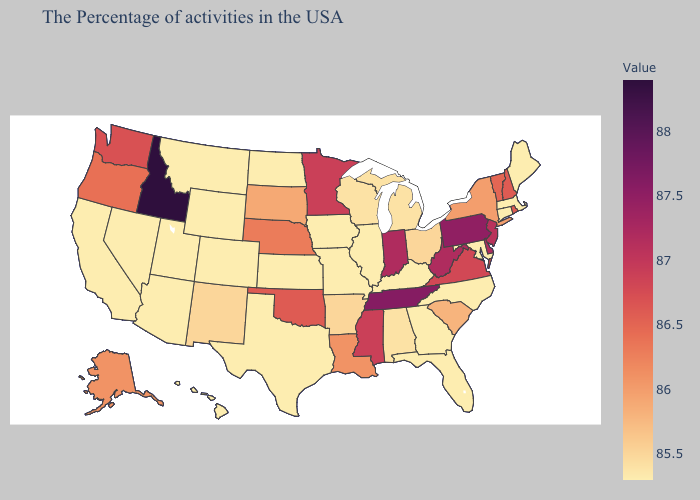Does the map have missing data?
Be succinct. No. Among the states that border New Jersey , does Delaware have the highest value?
Keep it brief. No. Which states have the lowest value in the USA?
Be succinct. Maine, Massachusetts, Connecticut, Maryland, North Carolina, Florida, Georgia, Kentucky, Illinois, Missouri, Iowa, Kansas, Texas, North Dakota, Wyoming, Colorado, Utah, Montana, Arizona, Nevada, California, Hawaii. Does Idaho have the highest value in the USA?
Concise answer only. Yes. Does the map have missing data?
Keep it brief. No. Among the states that border Ohio , which have the lowest value?
Short answer required. Kentucky. 